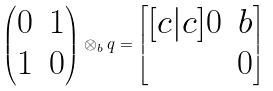<formula> <loc_0><loc_0><loc_500><loc_500>\begin{pmatrix} 0 & 1 \\ 1 & 0 \end{pmatrix} \otimes _ { b } q = \begin{bmatrix} [ c | c ] 0 & b \\ & 0 \end{bmatrix}</formula> 